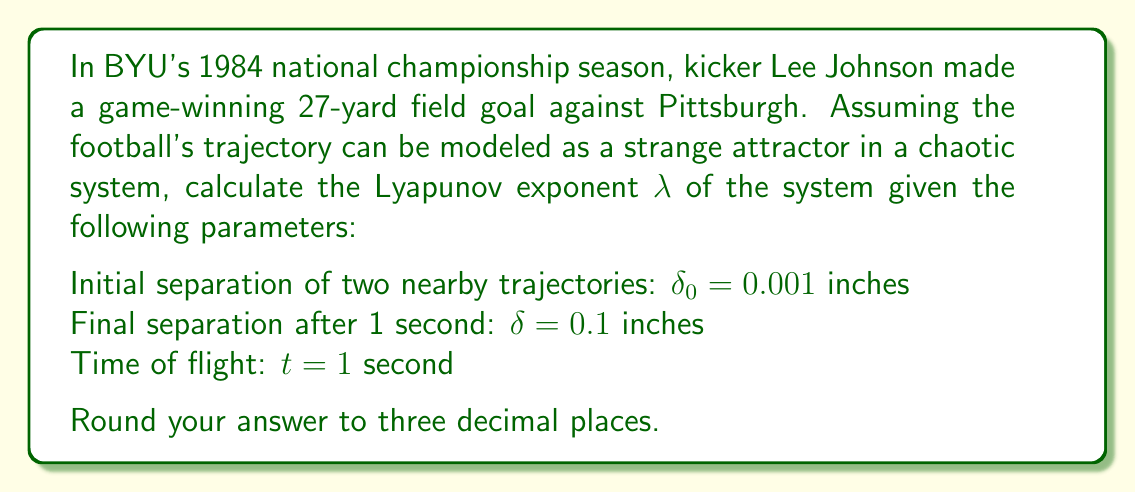Teach me how to tackle this problem. To solve this problem, we'll use the concept of Lyapunov exponents from chaos theory to analyze the divergence of two initially close trajectories in the football's path.

Step 1: Recall the formula for the Lyapunov exponent:
$$ λ = \frac{1}{t} \ln\left(\frac{δ}{δ_0}\right) $$

Step 2: Substitute the given values:
$t = 1$ second
$δ_0 = 0.001$ inches
$δ = 0.1$ inches

Step 3: Calculate the ratio inside the logarithm:
$$ \frac{δ}{δ_0} = \frac{0.1}{0.001} = 100 $$

Step 4: Apply the formula:
$$ λ = \frac{1}{1} \ln(100) $$

Step 5: Evaluate the natural logarithm:
$$ λ = \ln(100) \approx 4.60517 $$

Step 6: Round to three decimal places:
$$ λ ≈ 4.605 $$

The positive Lyapunov exponent indicates that the system is chaotic, which means small changes in initial conditions (like wind gusts or slight variations in the kick) can lead to significantly different trajectories for the football.
Answer: 4.605 